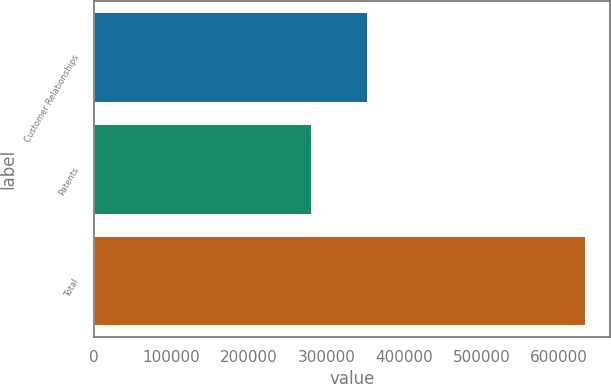Convert chart to OTSL. <chart><loc_0><loc_0><loc_500><loc_500><bar_chart><fcel>Customer Relationships<fcel>Patents<fcel>Total<nl><fcel>351873<fcel>280623<fcel>633985<nl></chart> 